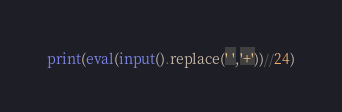Convert code to text. <code><loc_0><loc_0><loc_500><loc_500><_Python_>print(eval(input().replace(' ','+'))//24)</code> 